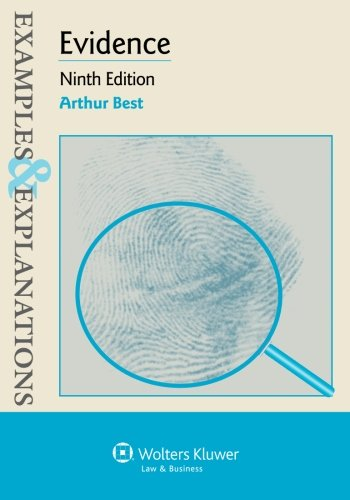What is the title of this book? The title of the book is 'Examples & Explanations: Evidence', which is a useful resource offering detailed explanations on the topic of evidence in law. 